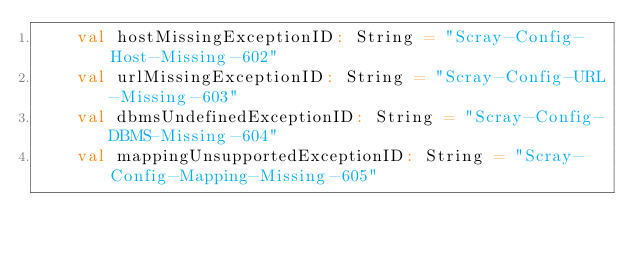Convert code to text. <code><loc_0><loc_0><loc_500><loc_500><_Scala_>    val hostMissingExceptionID: String = "Scray-Config-Host-Missing-602"
    val urlMissingExceptionID: String = "Scray-Config-URL-Missing-603"
    val dbmsUndefinedExceptionID: String = "Scray-Config-DBMS-Missing-604"
    val mappingUnsupportedExceptionID: String = "Scray-Config-Mapping-Missing-605"</code> 